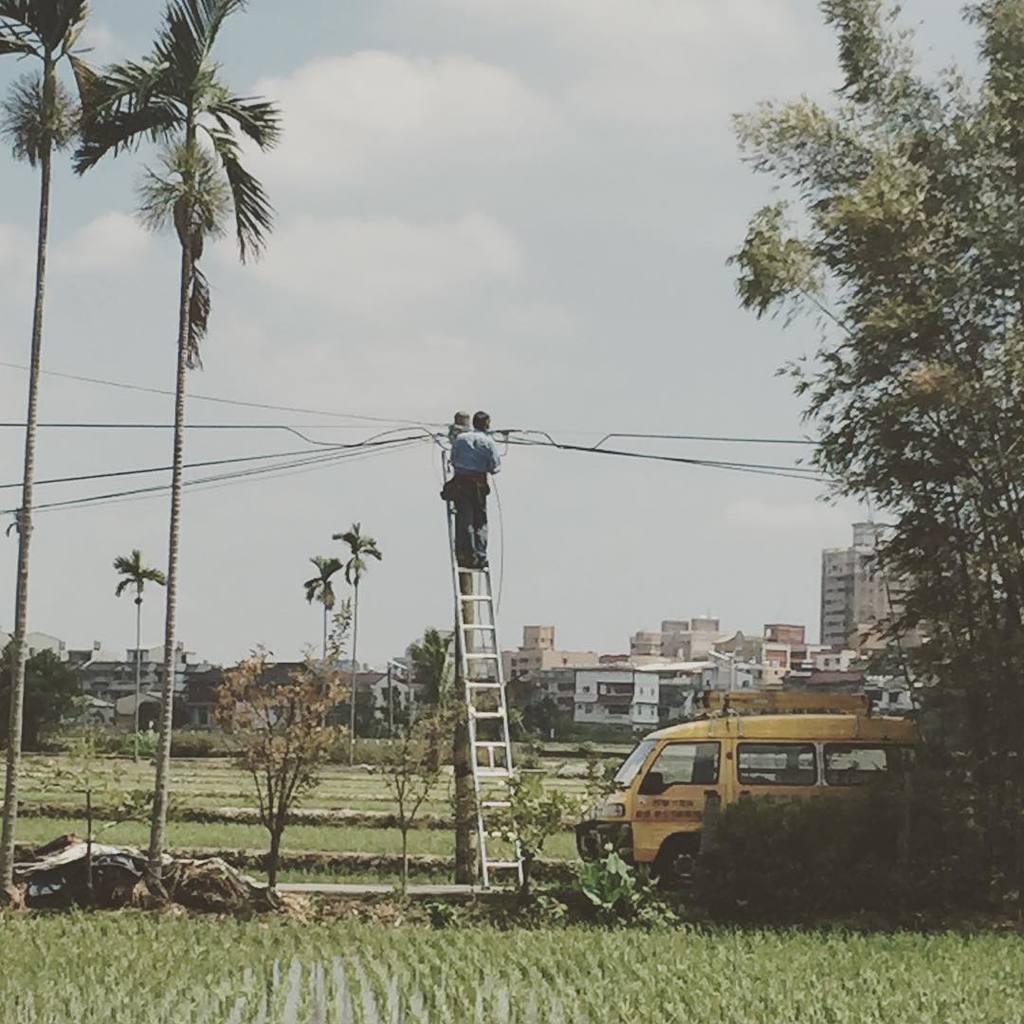Could you give a brief overview of what you see in this image? There is a man standing on a ladder which is sliding on the pole. He is servicing the wires which are passing through the poles. Beside the ladder there is a van which is in yellow colour. There are some plants and trees around the ladder. Here these are some crop fields. In the background we can observe some buildings here. Above the buildings there is a sky and clouds. 